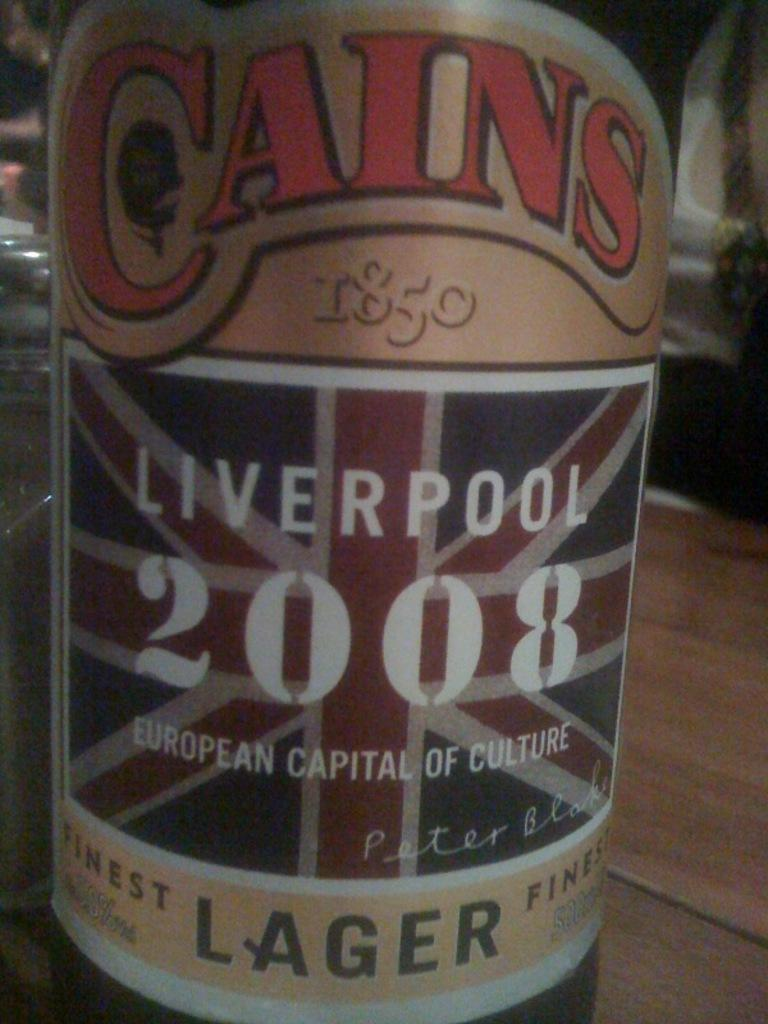Provide a one-sentence caption for the provided image. A bottle of 2008 Cains Lager is shown up close with its label in front. 